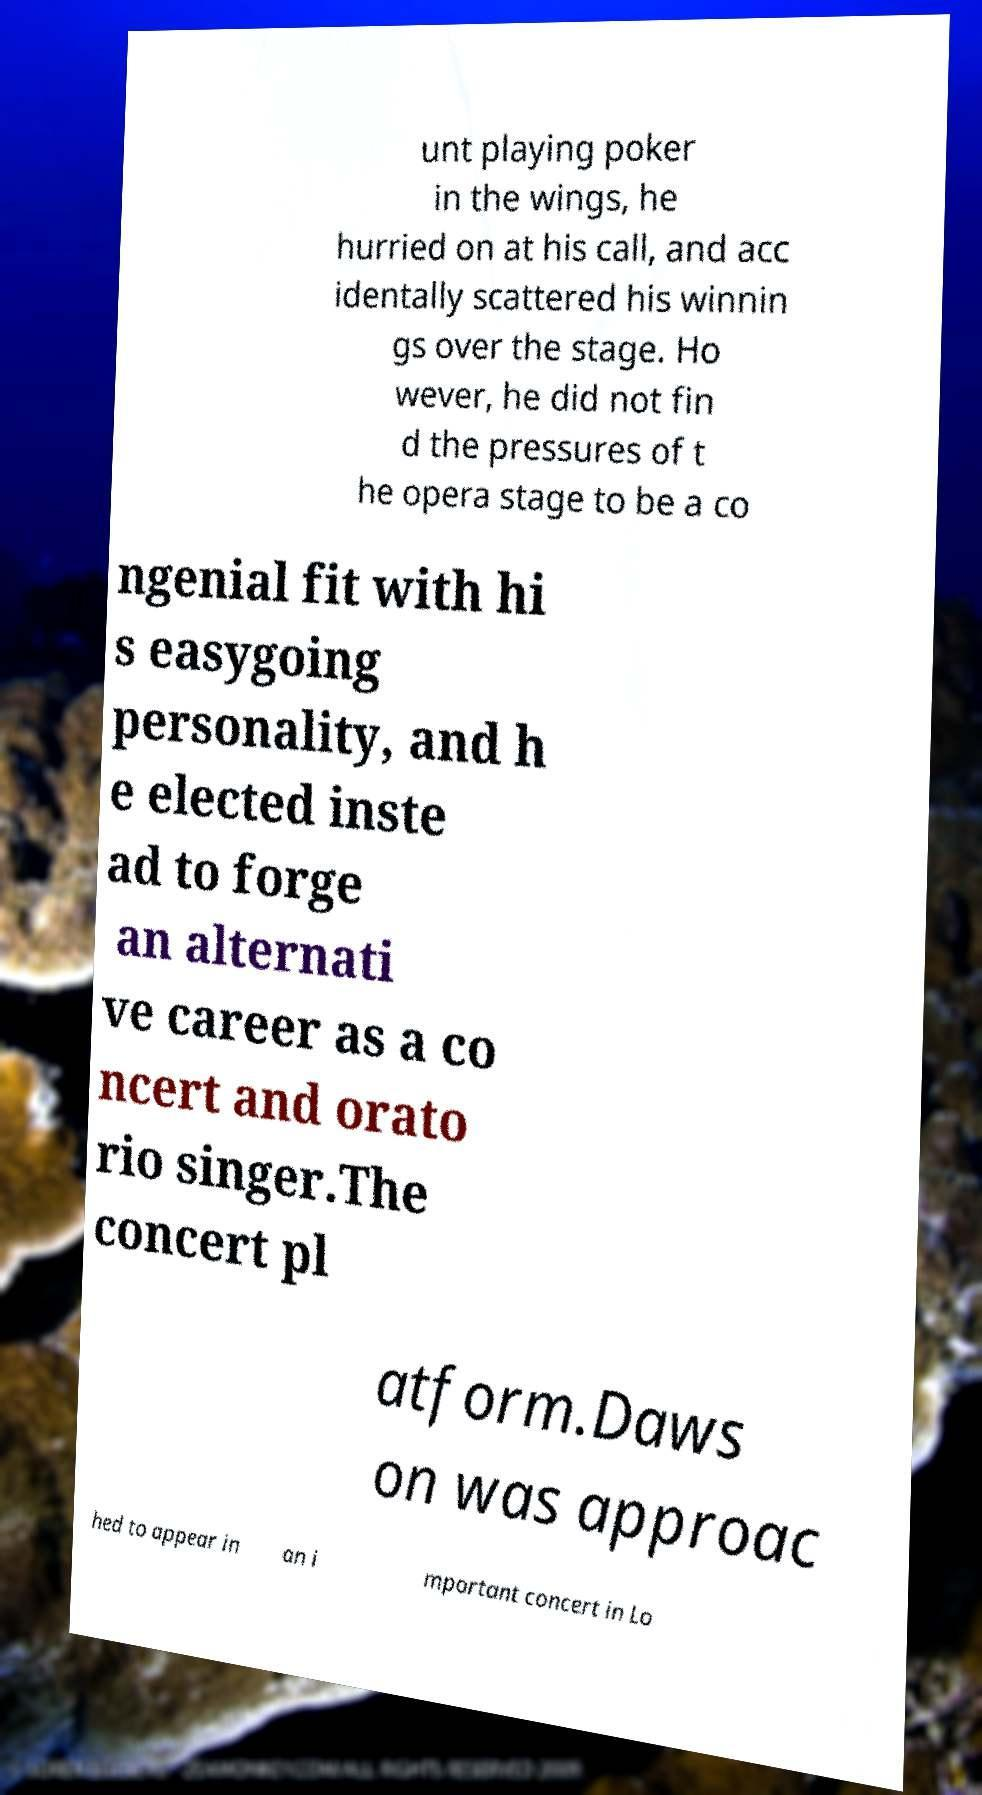Could you extract and type out the text from this image? unt playing poker in the wings, he hurried on at his call, and acc identally scattered his winnin gs over the stage. Ho wever, he did not fin d the pressures of t he opera stage to be a co ngenial fit with hi s easygoing personality, and h e elected inste ad to forge an alternati ve career as a co ncert and orato rio singer.The concert pl atform.Daws on was approac hed to appear in an i mportant concert in Lo 